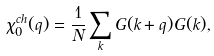Convert formula to latex. <formula><loc_0><loc_0><loc_500><loc_500>\chi ^ { c h } _ { 0 } ( { q } ) = \frac { 1 } { N } \sum _ { k } G ( { k + q } ) G ( { k } ) ,</formula> 